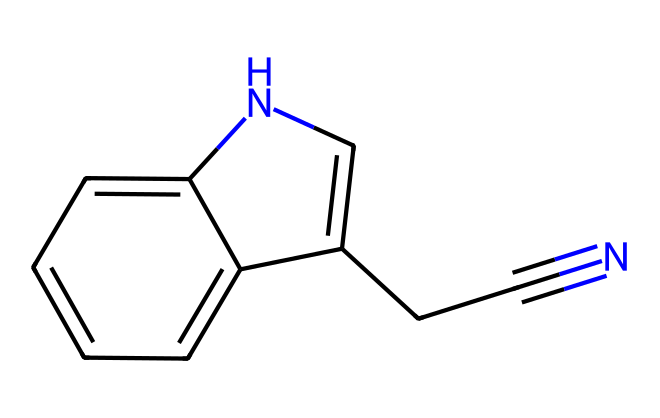What is the total number of carbon atoms in indole-3-acetonitrile? By examining the SMILES representation, we can identify the carbon atoms that form the backbone of the structure. Counting the "C" symbols present will yield the total number of carbon atoms. There are 11 carbon atoms in total.
Answer: 11 How many nitrogen atoms are present in the structure of indole-3-acetonitrile? In the SMILES, "N" represents nitrogen atoms. Carefully scanning through the structure, we can count the number of "N" occurrences. There are 2 nitrogen atoms in total.
Answer: 2 What functional group is represented by the “#N” in the structure? The “#N” notation indicates a triple bond to a nitrogen atom, which is characteristic of nitriles. This shows that the compound belongs to the nitrile functional group.
Answer: nitrile Is indole-3-acetonitrile a saturated or unsaturated compound? The presence of double bonds, indicated by "C=C" and the triple bond "C#N", signifies unsaturation in the molecule. Thus, it is classified as an unsaturated compound.
Answer: unsaturated What type of chemical is indole-3-acetonitrile considered (classify it)? Given its structure and the functional groups involved (the indole ring and the nitrile functional group), this compound is classified as a plant growth hormone.
Answer: plant growth hormone What is the molecular formula for indole-3-acetonitrile? To derive the molecular formula, we need to count the number of each atom type from the SMILES structure and then summarize it. The formula comprises 11 carbon atoms, 9 hydrogen atoms, 2 nitrogen atoms, leading to the molecular formula C11H9N2.
Answer: C11H9N2 